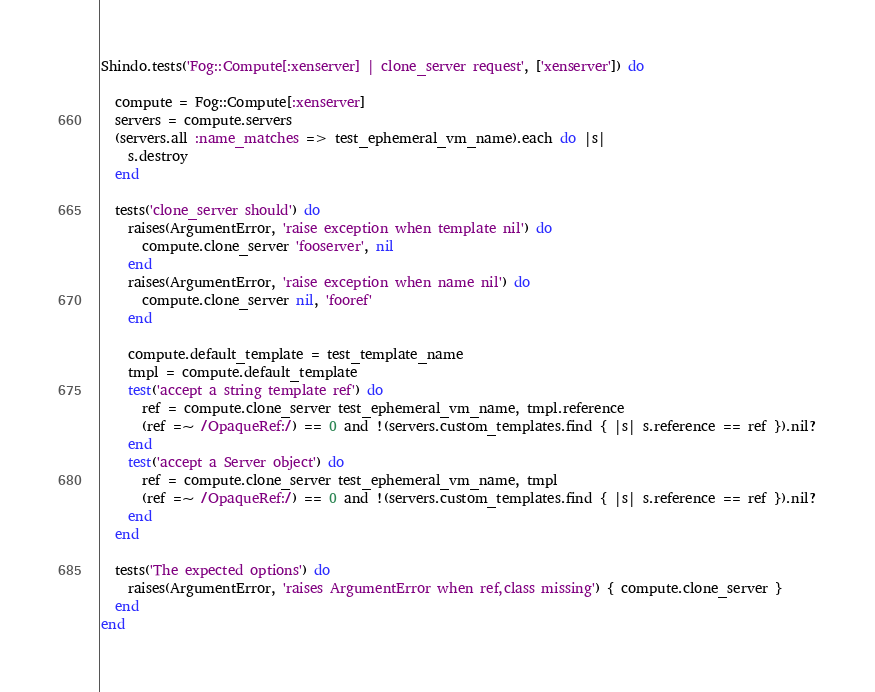<code> <loc_0><loc_0><loc_500><loc_500><_Ruby_>Shindo.tests('Fog::Compute[:xenserver] | clone_server request', ['xenserver']) do

  compute = Fog::Compute[:xenserver]
  servers = compute.servers
  (servers.all :name_matches => test_ephemeral_vm_name).each do |s|
    s.destroy
  end

  tests('clone_server should') do
    raises(ArgumentError, 'raise exception when template nil') do
      compute.clone_server 'fooserver', nil
    end
    raises(ArgumentError, 'raise exception when name nil') do
      compute.clone_server nil, 'fooref'
    end

    compute.default_template = test_template_name
    tmpl = compute.default_template
    test('accept a string template ref') do
      ref = compute.clone_server test_ephemeral_vm_name, tmpl.reference
      (ref =~ /OpaqueRef:/) == 0 and !(servers.custom_templates.find { |s| s.reference == ref }).nil?
    end
    test('accept a Server object') do
      ref = compute.clone_server test_ephemeral_vm_name, tmpl
      (ref =~ /OpaqueRef:/) == 0 and !(servers.custom_templates.find { |s| s.reference == ref }).nil?
    end
  end

  tests('The expected options') do
    raises(ArgumentError, 'raises ArgumentError when ref,class missing') { compute.clone_server }
  end
end
</code> 